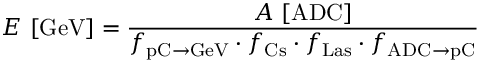Convert formula to latex. <formula><loc_0><loc_0><loc_500><loc_500>E \ [ G e V ] = \frac { A \ [ A D C ] } { f _ { p C \to G e V } \cdot f _ { C s } \cdot f _ { L a s } \cdot f _ { A D C \to p C } }</formula> 